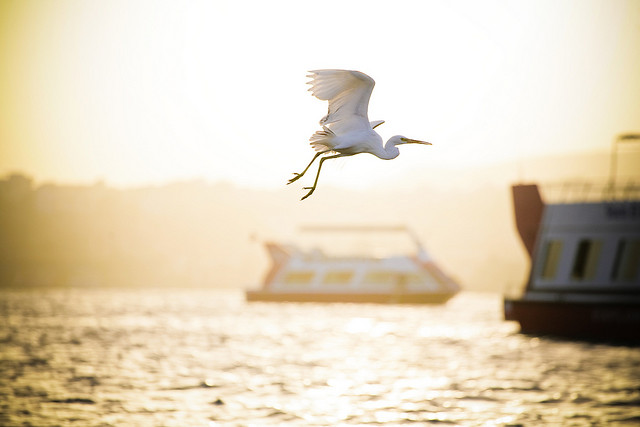Please provide the bounding box coordinate of the region this sentence describes: boat in center under bird. The bounding box coordinates for 'boat in center under bird' are [0.38, 0.51, 0.72, 0.64]. 